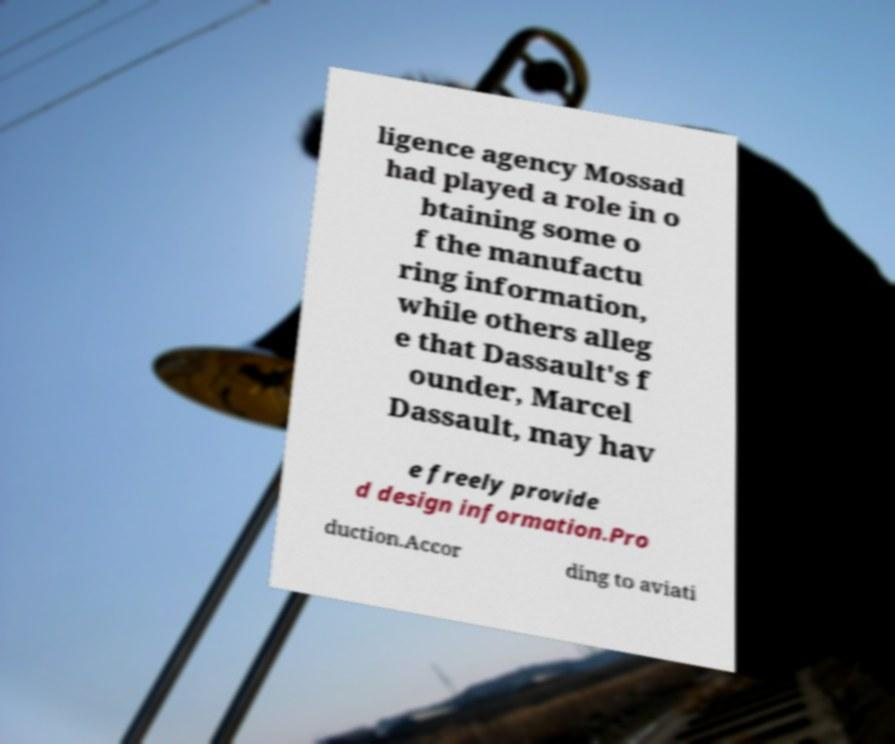I need the written content from this picture converted into text. Can you do that? ligence agency Mossad had played a role in o btaining some o f the manufactu ring information, while others alleg e that Dassault's f ounder, Marcel Dassault, may hav e freely provide d design information.Pro duction.Accor ding to aviati 